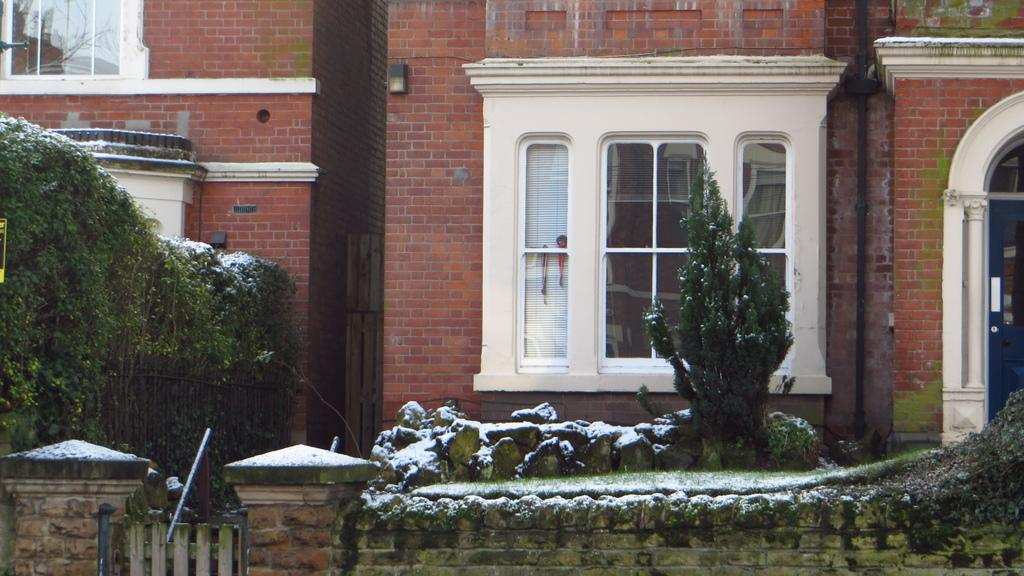What type of structures can be seen in the image? There are buildings in the image. What architectural features are visible on the buildings? There are windows, pipelines, and pillars visible on the buildings. What type of vegetation is present in the image? There are creepers, trees, and rocks visible in the image. What is the weather like in the image? There is snow visible in the image, indicating a cold climate. Can you see the mark that the monkey left on the grandfather's forehead in the image? There is no monkey or grandfather present in the image, so there is no mark to be seen. 